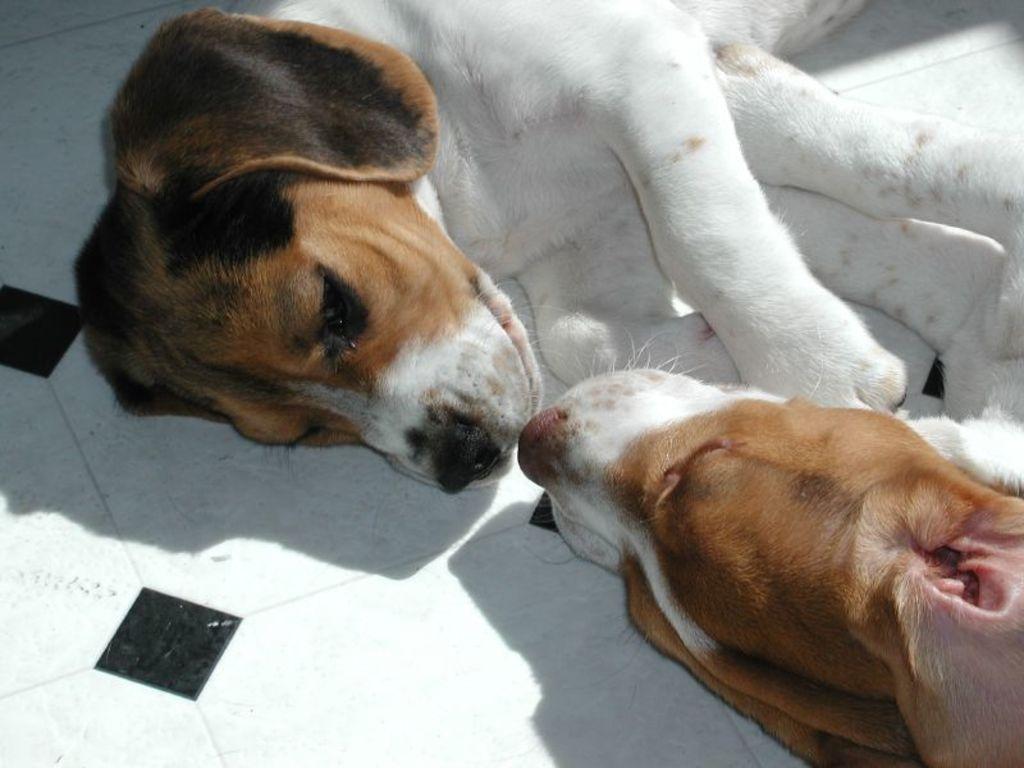Could you give a brief overview of what you see in this image? In this picture we can see two dogs lying on the floor. 